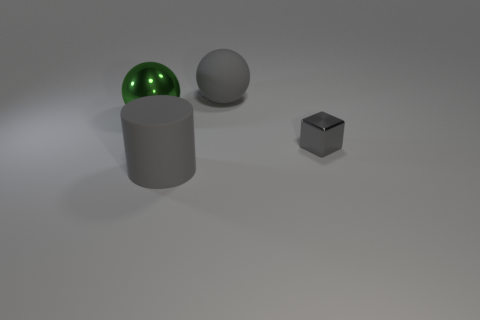Add 4 big rubber things. How many objects exist? 8 Subtract all cylinders. How many objects are left? 3 Add 3 small cyan rubber spheres. How many small cyan rubber spheres exist? 3 Subtract 0 cyan cylinders. How many objects are left? 4 Subtract all small rubber things. Subtract all green objects. How many objects are left? 3 Add 1 gray rubber cylinders. How many gray rubber cylinders are left? 2 